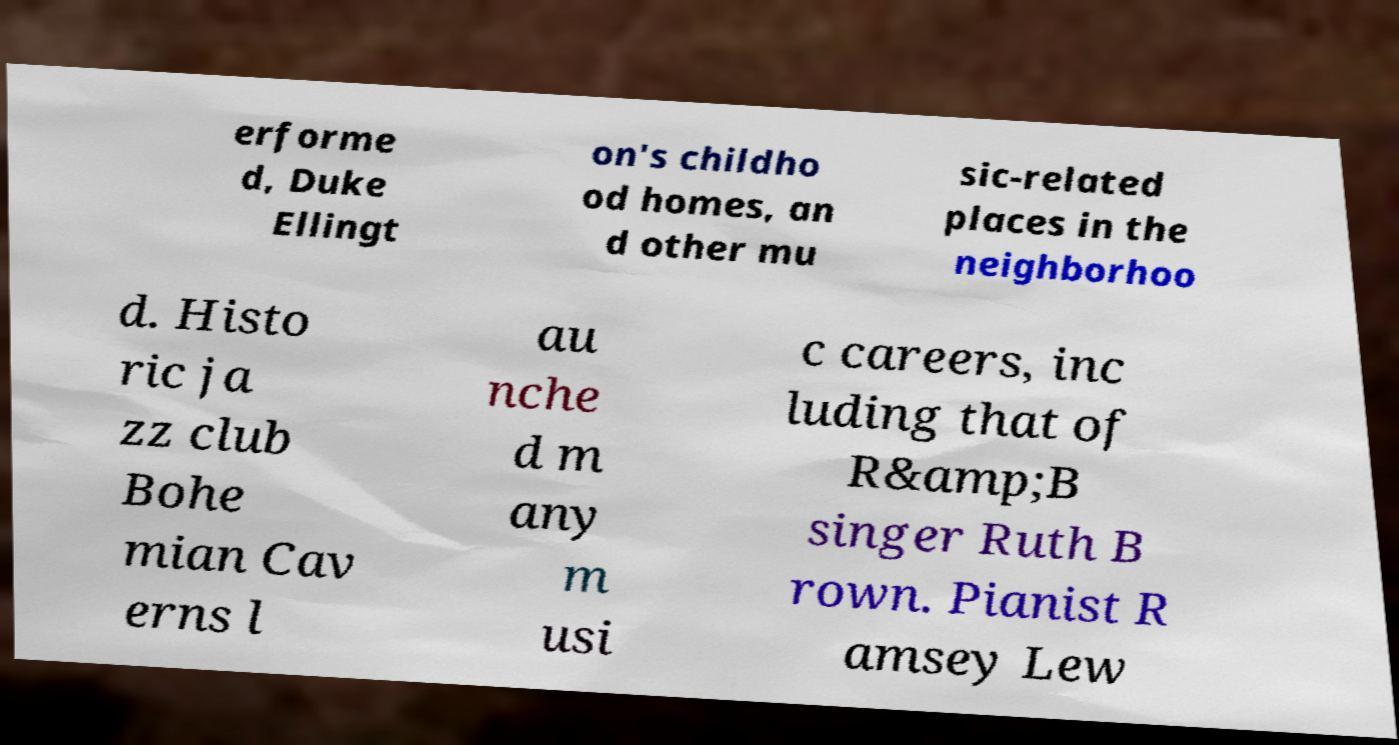I need the written content from this picture converted into text. Can you do that? erforme d, Duke Ellingt on's childho od homes, an d other mu sic-related places in the neighborhoo d. Histo ric ja zz club Bohe mian Cav erns l au nche d m any m usi c careers, inc luding that of R&amp;B singer Ruth B rown. Pianist R amsey Lew 